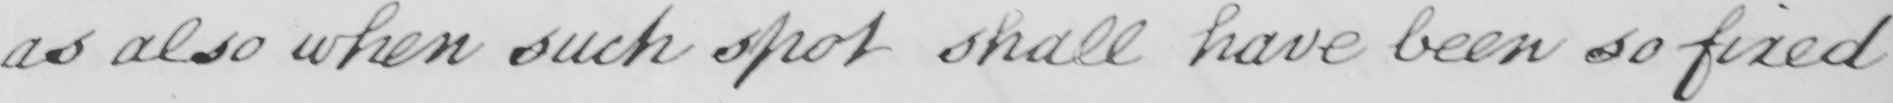Please provide the text content of this handwritten line. as also when such spot shall have been so fixed 